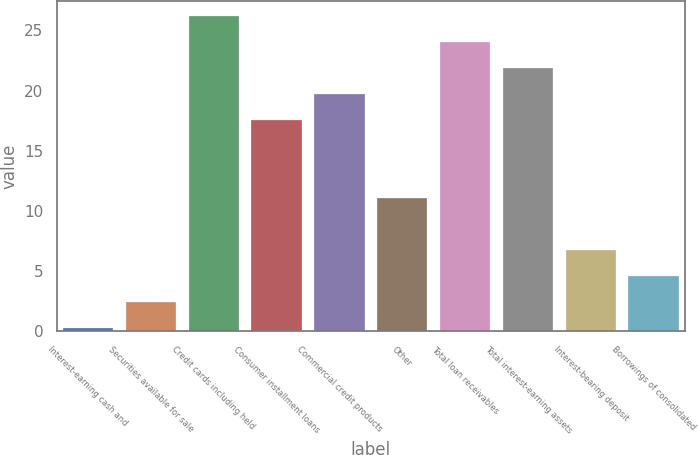Convert chart. <chart><loc_0><loc_0><loc_500><loc_500><bar_chart><fcel>Interest-earning cash and<fcel>Securities available for sale<fcel>Credit cards including held<fcel>Consumer installment loans<fcel>Commercial credit products<fcel>Other<fcel>Total loan receivables<fcel>Total interest-earning assets<fcel>Interest-bearing deposit<fcel>Borrowings of consolidated<nl><fcel>0.25<fcel>2.41<fcel>26.17<fcel>17.53<fcel>19.69<fcel>11.05<fcel>24.01<fcel>21.85<fcel>6.73<fcel>4.57<nl></chart> 